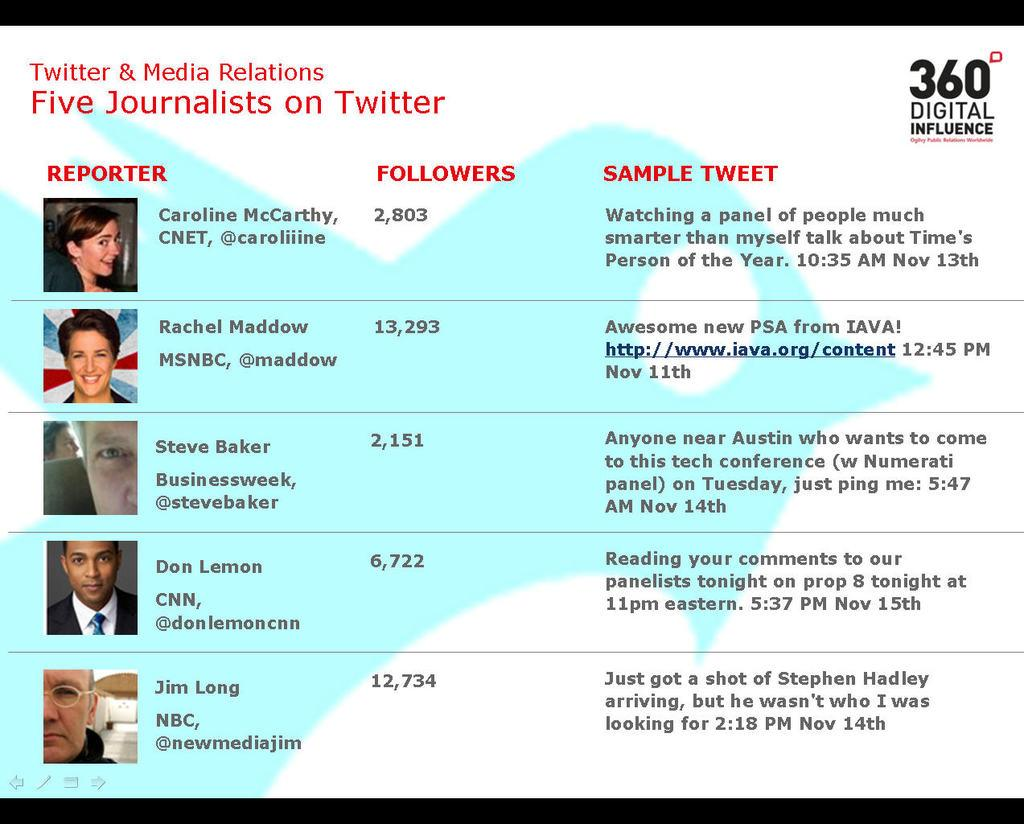What type of image is shown in the screenshot? The image contains a screenshot. What can be seen in the screenshot? There are pictures of persons in the screenshot. Is there any text present in the screenshot? Yes, there is text written on the screenshot. What colors are used for the background of the screenshot? The background color of the screenshot is a combination of white and blue. What type of car is being offered in the screenshot? There is no car present in the screenshot; it contains pictures of persons and text. How is the glue being used in the screenshot? There is no glue present in the screenshot; it is a digital image with pictures of persons, text, and a background color. 